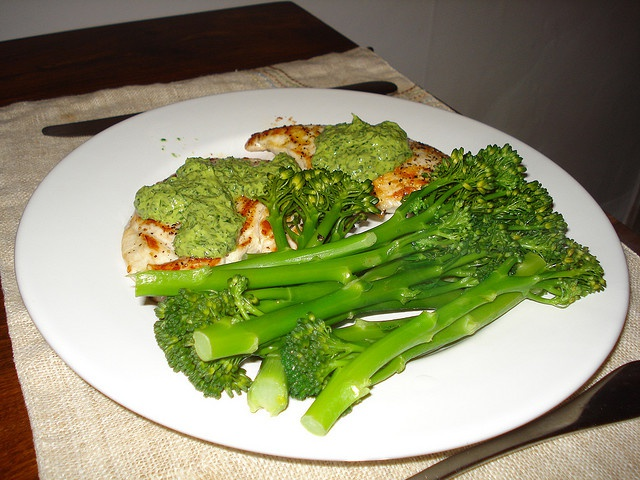Describe the objects in this image and their specific colors. I can see dining table in white, gray, black, olive, and darkgreen tones, broccoli in gray, olive, darkgreen, and white tones, broccoli in gray, olive, and lightgray tones, spoon in gray, black, and maroon tones, and knife in gray, black, and darkgray tones in this image. 